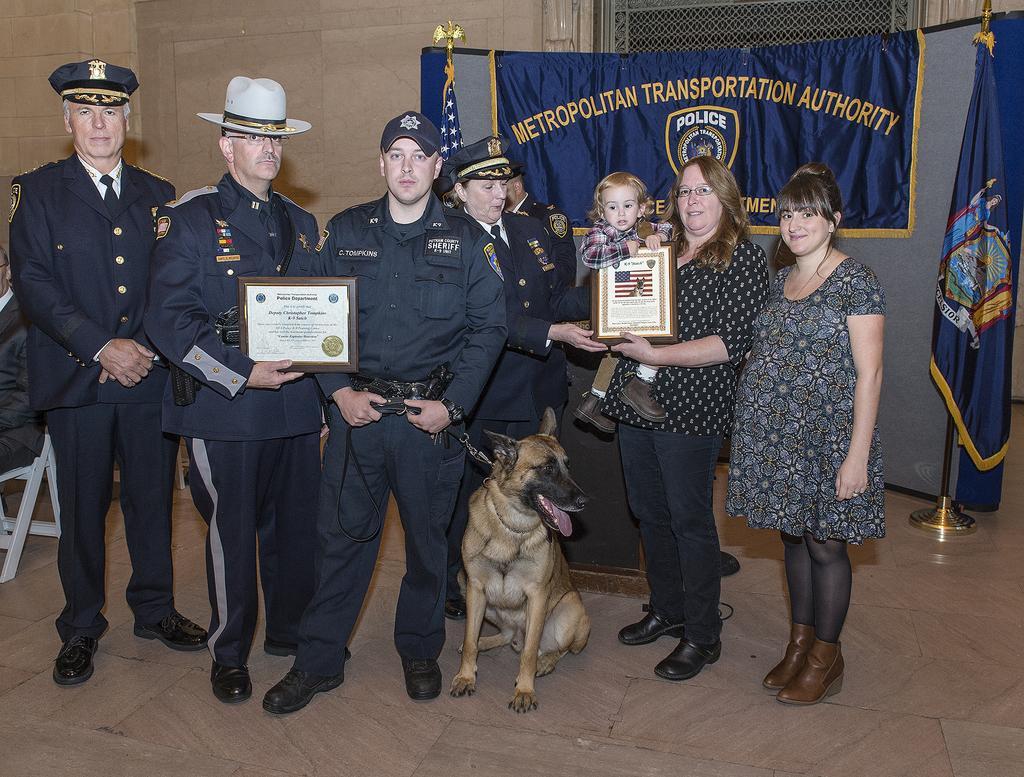Could you give a brief overview of what you see in this image? In this picture we can see a group of people standing and a dog on the ground where a man, two women and a child holding frames with their hands and in the background we can see a banner, flags, wall. 